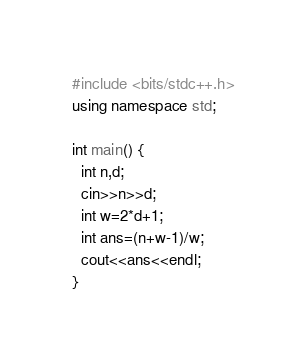<code> <loc_0><loc_0><loc_500><loc_500><_C++_>#include <bits/stdc++.h>
using namespace std;

int main() {
  int n,d;
  cin>>n>>d;
  int w=2*d+1;
  int ans=(n+w-1)/w;
  cout<<ans<<endl;
}</code> 